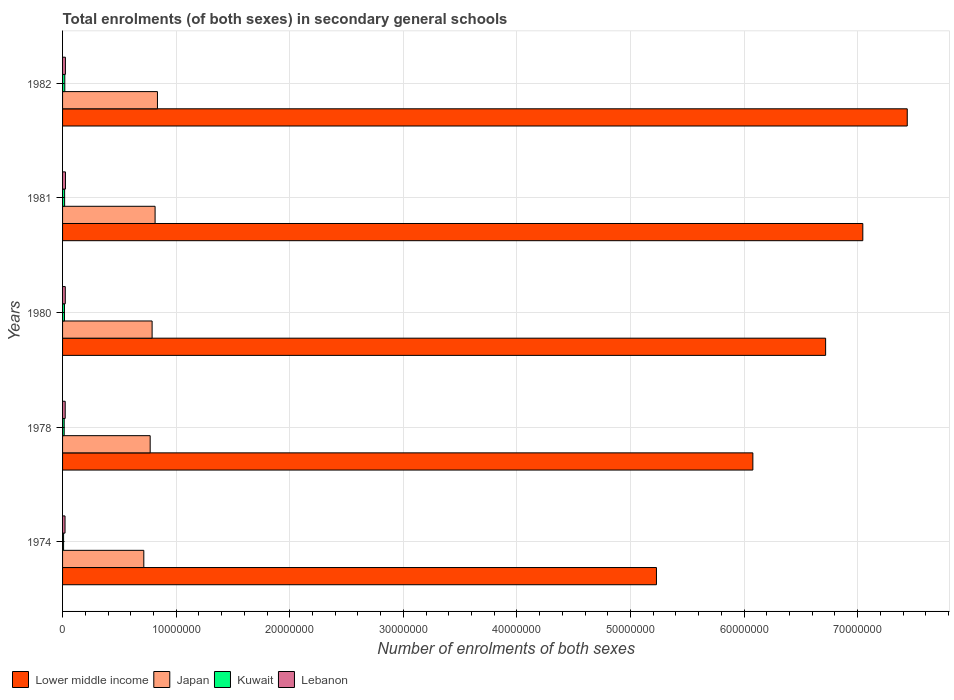Are the number of bars per tick equal to the number of legend labels?
Provide a short and direct response. Yes. How many bars are there on the 4th tick from the top?
Your response must be concise. 4. How many bars are there on the 1st tick from the bottom?
Your answer should be compact. 4. What is the label of the 1st group of bars from the top?
Your response must be concise. 1982. In how many cases, is the number of bars for a given year not equal to the number of legend labels?
Your answer should be compact. 0. What is the number of enrolments in secondary schools in Japan in 1980?
Make the answer very short. 7.88e+06. Across all years, what is the maximum number of enrolments in secondary schools in Japan?
Offer a terse response. 8.35e+06. Across all years, what is the minimum number of enrolments in secondary schools in Lower middle income?
Your answer should be compact. 5.23e+07. In which year was the number of enrolments in secondary schools in Kuwait maximum?
Offer a very short reply. 1982. In which year was the number of enrolments in secondary schools in Japan minimum?
Your answer should be very brief. 1974. What is the total number of enrolments in secondary schools in Lower middle income in the graph?
Provide a short and direct response. 3.25e+08. What is the difference between the number of enrolments in secondary schools in Lebanon in 1974 and that in 1982?
Keep it short and to the point. -3.33e+04. What is the difference between the number of enrolments in secondary schools in Japan in 1980 and the number of enrolments in secondary schools in Lebanon in 1974?
Provide a succinct answer. 7.67e+06. What is the average number of enrolments in secondary schools in Japan per year?
Offer a very short reply. 7.85e+06. In the year 1974, what is the difference between the number of enrolments in secondary schools in Lebanon and number of enrolments in secondary schools in Lower middle income?
Provide a succinct answer. -5.21e+07. In how many years, is the number of enrolments in secondary schools in Japan greater than 14000000 ?
Offer a terse response. 0. What is the ratio of the number of enrolments in secondary schools in Lebanon in 1981 to that in 1982?
Your answer should be compact. 1.02. Is the number of enrolments in secondary schools in Kuwait in 1974 less than that in 1982?
Make the answer very short. Yes. Is the difference between the number of enrolments in secondary schools in Lebanon in 1974 and 1982 greater than the difference between the number of enrolments in secondary schools in Lower middle income in 1974 and 1982?
Provide a succinct answer. Yes. What is the difference between the highest and the second highest number of enrolments in secondary schools in Lebanon?
Offer a very short reply. 4416. What is the difference between the highest and the lowest number of enrolments in secondary schools in Lebanon?
Ensure brevity in your answer.  3.77e+04. Is the sum of the number of enrolments in secondary schools in Lower middle income in 1978 and 1980 greater than the maximum number of enrolments in secondary schools in Lebanon across all years?
Make the answer very short. Yes. What does the 2nd bar from the top in 1982 represents?
Keep it short and to the point. Kuwait. What does the 3rd bar from the bottom in 1974 represents?
Give a very brief answer. Kuwait. Is it the case that in every year, the sum of the number of enrolments in secondary schools in Japan and number of enrolments in secondary schools in Lower middle income is greater than the number of enrolments in secondary schools in Kuwait?
Make the answer very short. Yes. How many bars are there?
Give a very brief answer. 20. Are all the bars in the graph horizontal?
Ensure brevity in your answer.  Yes. How many years are there in the graph?
Your response must be concise. 5. Are the values on the major ticks of X-axis written in scientific E-notation?
Offer a terse response. No. Does the graph contain any zero values?
Your answer should be compact. No. Does the graph contain grids?
Ensure brevity in your answer.  Yes. Where does the legend appear in the graph?
Ensure brevity in your answer.  Bottom left. What is the title of the graph?
Your answer should be very brief. Total enrolments (of both sexes) in secondary general schools. What is the label or title of the X-axis?
Keep it short and to the point. Number of enrolments of both sexes. What is the label or title of the Y-axis?
Keep it short and to the point. Years. What is the Number of enrolments of both sexes in Lower middle income in 1974?
Ensure brevity in your answer.  5.23e+07. What is the Number of enrolments of both sexes of Japan in 1974?
Ensure brevity in your answer.  7.15e+06. What is the Number of enrolments of both sexes of Kuwait in 1974?
Keep it short and to the point. 8.87e+04. What is the Number of enrolments of both sexes in Lebanon in 1974?
Offer a very short reply. 2.17e+05. What is the Number of enrolments of both sexes in Lower middle income in 1978?
Your answer should be very brief. 6.08e+07. What is the Number of enrolments of both sexes of Japan in 1978?
Your answer should be very brief. 7.71e+06. What is the Number of enrolments of both sexes of Kuwait in 1978?
Your answer should be compact. 1.43e+05. What is the Number of enrolments of both sexes of Lebanon in 1978?
Your answer should be very brief. 2.32e+05. What is the Number of enrolments of both sexes of Lower middle income in 1980?
Provide a succinct answer. 6.72e+07. What is the Number of enrolments of both sexes of Japan in 1980?
Keep it short and to the point. 7.88e+06. What is the Number of enrolments of both sexes of Kuwait in 1980?
Offer a very short reply. 1.67e+05. What is the Number of enrolments of both sexes in Lebanon in 1980?
Provide a short and direct response. 2.39e+05. What is the Number of enrolments of both sexes in Lower middle income in 1981?
Provide a succinct answer. 7.05e+07. What is the Number of enrolments of both sexes in Japan in 1981?
Offer a terse response. 8.15e+06. What is the Number of enrolments of both sexes in Kuwait in 1981?
Give a very brief answer. 1.81e+05. What is the Number of enrolments of both sexes in Lebanon in 1981?
Your answer should be very brief. 2.54e+05. What is the Number of enrolments of both sexes in Lower middle income in 1982?
Make the answer very short. 7.44e+07. What is the Number of enrolments of both sexes of Japan in 1982?
Your response must be concise. 8.35e+06. What is the Number of enrolments of both sexes of Kuwait in 1982?
Keep it short and to the point. 1.96e+05. What is the Number of enrolments of both sexes in Lebanon in 1982?
Offer a terse response. 2.50e+05. Across all years, what is the maximum Number of enrolments of both sexes of Lower middle income?
Provide a short and direct response. 7.44e+07. Across all years, what is the maximum Number of enrolments of both sexes of Japan?
Offer a very short reply. 8.35e+06. Across all years, what is the maximum Number of enrolments of both sexes in Kuwait?
Ensure brevity in your answer.  1.96e+05. Across all years, what is the maximum Number of enrolments of both sexes of Lebanon?
Make the answer very short. 2.54e+05. Across all years, what is the minimum Number of enrolments of both sexes in Lower middle income?
Your answer should be compact. 5.23e+07. Across all years, what is the minimum Number of enrolments of both sexes of Japan?
Your response must be concise. 7.15e+06. Across all years, what is the minimum Number of enrolments of both sexes of Kuwait?
Provide a short and direct response. 8.87e+04. Across all years, what is the minimum Number of enrolments of both sexes of Lebanon?
Keep it short and to the point. 2.17e+05. What is the total Number of enrolments of both sexes in Lower middle income in the graph?
Provide a short and direct response. 3.25e+08. What is the total Number of enrolments of both sexes in Japan in the graph?
Ensure brevity in your answer.  3.93e+07. What is the total Number of enrolments of both sexes in Kuwait in the graph?
Provide a short and direct response. 7.76e+05. What is the total Number of enrolments of both sexes in Lebanon in the graph?
Provide a succinct answer. 1.19e+06. What is the difference between the Number of enrolments of both sexes of Lower middle income in 1974 and that in 1978?
Provide a short and direct response. -8.49e+06. What is the difference between the Number of enrolments of both sexes in Japan in 1974 and that in 1978?
Provide a short and direct response. -5.60e+05. What is the difference between the Number of enrolments of both sexes of Kuwait in 1974 and that in 1978?
Your answer should be very brief. -5.38e+04. What is the difference between the Number of enrolments of both sexes in Lebanon in 1974 and that in 1978?
Your answer should be compact. -1.55e+04. What is the difference between the Number of enrolments of both sexes of Lower middle income in 1974 and that in 1980?
Keep it short and to the point. -1.49e+07. What is the difference between the Number of enrolments of both sexes in Japan in 1974 and that in 1980?
Your answer should be compact. -7.30e+05. What is the difference between the Number of enrolments of both sexes of Kuwait in 1974 and that in 1980?
Provide a succinct answer. -7.85e+04. What is the difference between the Number of enrolments of both sexes in Lebanon in 1974 and that in 1980?
Your answer should be very brief. -2.20e+04. What is the difference between the Number of enrolments of both sexes of Lower middle income in 1974 and that in 1981?
Provide a succinct answer. -1.82e+07. What is the difference between the Number of enrolments of both sexes of Japan in 1974 and that in 1981?
Ensure brevity in your answer.  -9.94e+05. What is the difference between the Number of enrolments of both sexes in Kuwait in 1974 and that in 1981?
Offer a very short reply. -9.27e+04. What is the difference between the Number of enrolments of both sexes in Lebanon in 1974 and that in 1981?
Your answer should be very brief. -3.77e+04. What is the difference between the Number of enrolments of both sexes in Lower middle income in 1974 and that in 1982?
Keep it short and to the point. -2.21e+07. What is the difference between the Number of enrolments of both sexes in Japan in 1974 and that in 1982?
Make the answer very short. -1.20e+06. What is the difference between the Number of enrolments of both sexes of Kuwait in 1974 and that in 1982?
Provide a succinct answer. -1.07e+05. What is the difference between the Number of enrolments of both sexes of Lebanon in 1974 and that in 1982?
Offer a terse response. -3.33e+04. What is the difference between the Number of enrolments of both sexes in Lower middle income in 1978 and that in 1980?
Offer a very short reply. -6.41e+06. What is the difference between the Number of enrolments of both sexes of Japan in 1978 and that in 1980?
Your response must be concise. -1.70e+05. What is the difference between the Number of enrolments of both sexes of Kuwait in 1978 and that in 1980?
Your answer should be compact. -2.47e+04. What is the difference between the Number of enrolments of both sexes of Lebanon in 1978 and that in 1980?
Ensure brevity in your answer.  -6518. What is the difference between the Number of enrolments of both sexes of Lower middle income in 1978 and that in 1981?
Offer a terse response. -9.68e+06. What is the difference between the Number of enrolments of both sexes in Japan in 1978 and that in 1981?
Your answer should be very brief. -4.34e+05. What is the difference between the Number of enrolments of both sexes in Kuwait in 1978 and that in 1981?
Your answer should be compact. -3.89e+04. What is the difference between the Number of enrolments of both sexes of Lebanon in 1978 and that in 1981?
Your response must be concise. -2.22e+04. What is the difference between the Number of enrolments of both sexes in Lower middle income in 1978 and that in 1982?
Keep it short and to the point. -1.36e+07. What is the difference between the Number of enrolments of both sexes in Japan in 1978 and that in 1982?
Your answer should be compact. -6.41e+05. What is the difference between the Number of enrolments of both sexes in Kuwait in 1978 and that in 1982?
Provide a succinct answer. -5.32e+04. What is the difference between the Number of enrolments of both sexes in Lebanon in 1978 and that in 1982?
Offer a terse response. -1.78e+04. What is the difference between the Number of enrolments of both sexes of Lower middle income in 1980 and that in 1981?
Give a very brief answer. -3.27e+06. What is the difference between the Number of enrolments of both sexes in Japan in 1980 and that in 1981?
Provide a short and direct response. -2.63e+05. What is the difference between the Number of enrolments of both sexes in Kuwait in 1980 and that in 1981?
Offer a very short reply. -1.42e+04. What is the difference between the Number of enrolments of both sexes in Lebanon in 1980 and that in 1981?
Keep it short and to the point. -1.57e+04. What is the difference between the Number of enrolments of both sexes of Lower middle income in 1980 and that in 1982?
Offer a terse response. -7.19e+06. What is the difference between the Number of enrolments of both sexes of Japan in 1980 and that in 1982?
Your response must be concise. -4.71e+05. What is the difference between the Number of enrolments of both sexes in Kuwait in 1980 and that in 1982?
Your answer should be very brief. -2.85e+04. What is the difference between the Number of enrolments of both sexes in Lebanon in 1980 and that in 1982?
Keep it short and to the point. -1.13e+04. What is the difference between the Number of enrolments of both sexes of Lower middle income in 1981 and that in 1982?
Ensure brevity in your answer.  -3.91e+06. What is the difference between the Number of enrolments of both sexes in Japan in 1981 and that in 1982?
Your response must be concise. -2.07e+05. What is the difference between the Number of enrolments of both sexes in Kuwait in 1981 and that in 1982?
Offer a terse response. -1.43e+04. What is the difference between the Number of enrolments of both sexes in Lebanon in 1981 and that in 1982?
Provide a short and direct response. 4416. What is the difference between the Number of enrolments of both sexes in Lower middle income in 1974 and the Number of enrolments of both sexes in Japan in 1978?
Ensure brevity in your answer.  4.46e+07. What is the difference between the Number of enrolments of both sexes in Lower middle income in 1974 and the Number of enrolments of both sexes in Kuwait in 1978?
Your response must be concise. 5.21e+07. What is the difference between the Number of enrolments of both sexes in Lower middle income in 1974 and the Number of enrolments of both sexes in Lebanon in 1978?
Offer a very short reply. 5.21e+07. What is the difference between the Number of enrolments of both sexes of Japan in 1974 and the Number of enrolments of both sexes of Kuwait in 1978?
Provide a short and direct response. 7.01e+06. What is the difference between the Number of enrolments of both sexes in Japan in 1974 and the Number of enrolments of both sexes in Lebanon in 1978?
Keep it short and to the point. 6.92e+06. What is the difference between the Number of enrolments of both sexes in Kuwait in 1974 and the Number of enrolments of both sexes in Lebanon in 1978?
Offer a very short reply. -1.44e+05. What is the difference between the Number of enrolments of both sexes of Lower middle income in 1974 and the Number of enrolments of both sexes of Japan in 1980?
Give a very brief answer. 4.44e+07. What is the difference between the Number of enrolments of both sexes in Lower middle income in 1974 and the Number of enrolments of both sexes in Kuwait in 1980?
Your answer should be very brief. 5.21e+07. What is the difference between the Number of enrolments of both sexes in Lower middle income in 1974 and the Number of enrolments of both sexes in Lebanon in 1980?
Offer a terse response. 5.20e+07. What is the difference between the Number of enrolments of both sexes of Japan in 1974 and the Number of enrolments of both sexes of Kuwait in 1980?
Provide a short and direct response. 6.99e+06. What is the difference between the Number of enrolments of both sexes of Japan in 1974 and the Number of enrolments of both sexes of Lebanon in 1980?
Make the answer very short. 6.91e+06. What is the difference between the Number of enrolments of both sexes of Kuwait in 1974 and the Number of enrolments of both sexes of Lebanon in 1980?
Your response must be concise. -1.50e+05. What is the difference between the Number of enrolments of both sexes in Lower middle income in 1974 and the Number of enrolments of both sexes in Japan in 1981?
Your answer should be compact. 4.41e+07. What is the difference between the Number of enrolments of both sexes in Lower middle income in 1974 and the Number of enrolments of both sexes in Kuwait in 1981?
Give a very brief answer. 5.21e+07. What is the difference between the Number of enrolments of both sexes in Lower middle income in 1974 and the Number of enrolments of both sexes in Lebanon in 1981?
Offer a very short reply. 5.20e+07. What is the difference between the Number of enrolments of both sexes in Japan in 1974 and the Number of enrolments of both sexes in Kuwait in 1981?
Ensure brevity in your answer.  6.97e+06. What is the difference between the Number of enrolments of both sexes in Japan in 1974 and the Number of enrolments of both sexes in Lebanon in 1981?
Make the answer very short. 6.90e+06. What is the difference between the Number of enrolments of both sexes in Kuwait in 1974 and the Number of enrolments of both sexes in Lebanon in 1981?
Make the answer very short. -1.66e+05. What is the difference between the Number of enrolments of both sexes of Lower middle income in 1974 and the Number of enrolments of both sexes of Japan in 1982?
Make the answer very short. 4.39e+07. What is the difference between the Number of enrolments of both sexes of Lower middle income in 1974 and the Number of enrolments of both sexes of Kuwait in 1982?
Your answer should be very brief. 5.21e+07. What is the difference between the Number of enrolments of both sexes of Lower middle income in 1974 and the Number of enrolments of both sexes of Lebanon in 1982?
Offer a very short reply. 5.20e+07. What is the difference between the Number of enrolments of both sexes of Japan in 1974 and the Number of enrolments of both sexes of Kuwait in 1982?
Keep it short and to the point. 6.96e+06. What is the difference between the Number of enrolments of both sexes of Japan in 1974 and the Number of enrolments of both sexes of Lebanon in 1982?
Your answer should be very brief. 6.90e+06. What is the difference between the Number of enrolments of both sexes in Kuwait in 1974 and the Number of enrolments of both sexes in Lebanon in 1982?
Ensure brevity in your answer.  -1.61e+05. What is the difference between the Number of enrolments of both sexes in Lower middle income in 1978 and the Number of enrolments of both sexes in Japan in 1980?
Provide a short and direct response. 5.29e+07. What is the difference between the Number of enrolments of both sexes in Lower middle income in 1978 and the Number of enrolments of both sexes in Kuwait in 1980?
Provide a short and direct response. 6.06e+07. What is the difference between the Number of enrolments of both sexes of Lower middle income in 1978 and the Number of enrolments of both sexes of Lebanon in 1980?
Your answer should be compact. 6.05e+07. What is the difference between the Number of enrolments of both sexes of Japan in 1978 and the Number of enrolments of both sexes of Kuwait in 1980?
Provide a short and direct response. 7.55e+06. What is the difference between the Number of enrolments of both sexes of Japan in 1978 and the Number of enrolments of both sexes of Lebanon in 1980?
Your answer should be compact. 7.47e+06. What is the difference between the Number of enrolments of both sexes in Kuwait in 1978 and the Number of enrolments of both sexes in Lebanon in 1980?
Make the answer very short. -9.63e+04. What is the difference between the Number of enrolments of both sexes in Lower middle income in 1978 and the Number of enrolments of both sexes in Japan in 1981?
Provide a short and direct response. 5.26e+07. What is the difference between the Number of enrolments of both sexes in Lower middle income in 1978 and the Number of enrolments of both sexes in Kuwait in 1981?
Offer a terse response. 6.06e+07. What is the difference between the Number of enrolments of both sexes in Lower middle income in 1978 and the Number of enrolments of both sexes in Lebanon in 1981?
Give a very brief answer. 6.05e+07. What is the difference between the Number of enrolments of both sexes in Japan in 1978 and the Number of enrolments of both sexes in Kuwait in 1981?
Provide a short and direct response. 7.53e+06. What is the difference between the Number of enrolments of both sexes in Japan in 1978 and the Number of enrolments of both sexes in Lebanon in 1981?
Offer a very short reply. 7.46e+06. What is the difference between the Number of enrolments of both sexes of Kuwait in 1978 and the Number of enrolments of both sexes of Lebanon in 1981?
Your answer should be very brief. -1.12e+05. What is the difference between the Number of enrolments of both sexes of Lower middle income in 1978 and the Number of enrolments of both sexes of Japan in 1982?
Your answer should be compact. 5.24e+07. What is the difference between the Number of enrolments of both sexes of Lower middle income in 1978 and the Number of enrolments of both sexes of Kuwait in 1982?
Offer a very short reply. 6.06e+07. What is the difference between the Number of enrolments of both sexes in Lower middle income in 1978 and the Number of enrolments of both sexes in Lebanon in 1982?
Provide a short and direct response. 6.05e+07. What is the difference between the Number of enrolments of both sexes of Japan in 1978 and the Number of enrolments of both sexes of Kuwait in 1982?
Offer a very short reply. 7.52e+06. What is the difference between the Number of enrolments of both sexes of Japan in 1978 and the Number of enrolments of both sexes of Lebanon in 1982?
Your answer should be compact. 7.46e+06. What is the difference between the Number of enrolments of both sexes in Kuwait in 1978 and the Number of enrolments of both sexes in Lebanon in 1982?
Provide a succinct answer. -1.08e+05. What is the difference between the Number of enrolments of both sexes of Lower middle income in 1980 and the Number of enrolments of both sexes of Japan in 1981?
Give a very brief answer. 5.90e+07. What is the difference between the Number of enrolments of both sexes in Lower middle income in 1980 and the Number of enrolments of both sexes in Kuwait in 1981?
Your answer should be compact. 6.70e+07. What is the difference between the Number of enrolments of both sexes of Lower middle income in 1980 and the Number of enrolments of both sexes of Lebanon in 1981?
Keep it short and to the point. 6.69e+07. What is the difference between the Number of enrolments of both sexes of Japan in 1980 and the Number of enrolments of both sexes of Kuwait in 1981?
Offer a very short reply. 7.70e+06. What is the difference between the Number of enrolments of both sexes of Japan in 1980 and the Number of enrolments of both sexes of Lebanon in 1981?
Ensure brevity in your answer.  7.63e+06. What is the difference between the Number of enrolments of both sexes in Kuwait in 1980 and the Number of enrolments of both sexes in Lebanon in 1981?
Give a very brief answer. -8.72e+04. What is the difference between the Number of enrolments of both sexes in Lower middle income in 1980 and the Number of enrolments of both sexes in Japan in 1982?
Ensure brevity in your answer.  5.88e+07. What is the difference between the Number of enrolments of both sexes in Lower middle income in 1980 and the Number of enrolments of both sexes in Kuwait in 1982?
Keep it short and to the point. 6.70e+07. What is the difference between the Number of enrolments of both sexes of Lower middle income in 1980 and the Number of enrolments of both sexes of Lebanon in 1982?
Your answer should be very brief. 6.69e+07. What is the difference between the Number of enrolments of both sexes of Japan in 1980 and the Number of enrolments of both sexes of Kuwait in 1982?
Offer a terse response. 7.69e+06. What is the difference between the Number of enrolments of both sexes of Japan in 1980 and the Number of enrolments of both sexes of Lebanon in 1982?
Your answer should be very brief. 7.63e+06. What is the difference between the Number of enrolments of both sexes in Kuwait in 1980 and the Number of enrolments of both sexes in Lebanon in 1982?
Your response must be concise. -8.28e+04. What is the difference between the Number of enrolments of both sexes in Lower middle income in 1981 and the Number of enrolments of both sexes in Japan in 1982?
Provide a short and direct response. 6.21e+07. What is the difference between the Number of enrolments of both sexes of Lower middle income in 1981 and the Number of enrolments of both sexes of Kuwait in 1982?
Provide a succinct answer. 7.03e+07. What is the difference between the Number of enrolments of both sexes in Lower middle income in 1981 and the Number of enrolments of both sexes in Lebanon in 1982?
Give a very brief answer. 7.02e+07. What is the difference between the Number of enrolments of both sexes of Japan in 1981 and the Number of enrolments of both sexes of Kuwait in 1982?
Your answer should be compact. 7.95e+06. What is the difference between the Number of enrolments of both sexes in Japan in 1981 and the Number of enrolments of both sexes in Lebanon in 1982?
Provide a short and direct response. 7.90e+06. What is the difference between the Number of enrolments of both sexes of Kuwait in 1981 and the Number of enrolments of both sexes of Lebanon in 1982?
Your response must be concise. -6.86e+04. What is the average Number of enrolments of both sexes of Lower middle income per year?
Keep it short and to the point. 6.50e+07. What is the average Number of enrolments of both sexes of Japan per year?
Your response must be concise. 7.85e+06. What is the average Number of enrolments of both sexes in Kuwait per year?
Your answer should be very brief. 1.55e+05. What is the average Number of enrolments of both sexes in Lebanon per year?
Make the answer very short. 2.38e+05. In the year 1974, what is the difference between the Number of enrolments of both sexes in Lower middle income and Number of enrolments of both sexes in Japan?
Ensure brevity in your answer.  4.51e+07. In the year 1974, what is the difference between the Number of enrolments of both sexes in Lower middle income and Number of enrolments of both sexes in Kuwait?
Your answer should be very brief. 5.22e+07. In the year 1974, what is the difference between the Number of enrolments of both sexes in Lower middle income and Number of enrolments of both sexes in Lebanon?
Your response must be concise. 5.21e+07. In the year 1974, what is the difference between the Number of enrolments of both sexes of Japan and Number of enrolments of both sexes of Kuwait?
Ensure brevity in your answer.  7.06e+06. In the year 1974, what is the difference between the Number of enrolments of both sexes in Japan and Number of enrolments of both sexes in Lebanon?
Give a very brief answer. 6.94e+06. In the year 1974, what is the difference between the Number of enrolments of both sexes in Kuwait and Number of enrolments of both sexes in Lebanon?
Give a very brief answer. -1.28e+05. In the year 1978, what is the difference between the Number of enrolments of both sexes of Lower middle income and Number of enrolments of both sexes of Japan?
Provide a short and direct response. 5.31e+07. In the year 1978, what is the difference between the Number of enrolments of both sexes of Lower middle income and Number of enrolments of both sexes of Kuwait?
Offer a terse response. 6.06e+07. In the year 1978, what is the difference between the Number of enrolments of both sexes in Lower middle income and Number of enrolments of both sexes in Lebanon?
Provide a succinct answer. 6.05e+07. In the year 1978, what is the difference between the Number of enrolments of both sexes of Japan and Number of enrolments of both sexes of Kuwait?
Your answer should be compact. 7.57e+06. In the year 1978, what is the difference between the Number of enrolments of both sexes of Japan and Number of enrolments of both sexes of Lebanon?
Offer a very short reply. 7.48e+06. In the year 1978, what is the difference between the Number of enrolments of both sexes in Kuwait and Number of enrolments of both sexes in Lebanon?
Provide a succinct answer. -8.97e+04. In the year 1980, what is the difference between the Number of enrolments of both sexes of Lower middle income and Number of enrolments of both sexes of Japan?
Make the answer very short. 5.93e+07. In the year 1980, what is the difference between the Number of enrolments of both sexes in Lower middle income and Number of enrolments of both sexes in Kuwait?
Offer a terse response. 6.70e+07. In the year 1980, what is the difference between the Number of enrolments of both sexes of Lower middle income and Number of enrolments of both sexes of Lebanon?
Give a very brief answer. 6.69e+07. In the year 1980, what is the difference between the Number of enrolments of both sexes in Japan and Number of enrolments of both sexes in Kuwait?
Your answer should be compact. 7.72e+06. In the year 1980, what is the difference between the Number of enrolments of both sexes of Japan and Number of enrolments of both sexes of Lebanon?
Your response must be concise. 7.64e+06. In the year 1980, what is the difference between the Number of enrolments of both sexes in Kuwait and Number of enrolments of both sexes in Lebanon?
Provide a succinct answer. -7.15e+04. In the year 1981, what is the difference between the Number of enrolments of both sexes in Lower middle income and Number of enrolments of both sexes in Japan?
Provide a succinct answer. 6.23e+07. In the year 1981, what is the difference between the Number of enrolments of both sexes of Lower middle income and Number of enrolments of both sexes of Kuwait?
Your answer should be compact. 7.03e+07. In the year 1981, what is the difference between the Number of enrolments of both sexes in Lower middle income and Number of enrolments of both sexes in Lebanon?
Keep it short and to the point. 7.02e+07. In the year 1981, what is the difference between the Number of enrolments of both sexes of Japan and Number of enrolments of both sexes of Kuwait?
Your answer should be compact. 7.97e+06. In the year 1981, what is the difference between the Number of enrolments of both sexes of Japan and Number of enrolments of both sexes of Lebanon?
Provide a short and direct response. 7.89e+06. In the year 1981, what is the difference between the Number of enrolments of both sexes in Kuwait and Number of enrolments of both sexes in Lebanon?
Provide a short and direct response. -7.30e+04. In the year 1982, what is the difference between the Number of enrolments of both sexes of Lower middle income and Number of enrolments of both sexes of Japan?
Give a very brief answer. 6.60e+07. In the year 1982, what is the difference between the Number of enrolments of both sexes in Lower middle income and Number of enrolments of both sexes in Kuwait?
Your answer should be very brief. 7.42e+07. In the year 1982, what is the difference between the Number of enrolments of both sexes of Lower middle income and Number of enrolments of both sexes of Lebanon?
Provide a succinct answer. 7.41e+07. In the year 1982, what is the difference between the Number of enrolments of both sexes of Japan and Number of enrolments of both sexes of Kuwait?
Provide a succinct answer. 8.16e+06. In the year 1982, what is the difference between the Number of enrolments of both sexes of Japan and Number of enrolments of both sexes of Lebanon?
Provide a short and direct response. 8.10e+06. In the year 1982, what is the difference between the Number of enrolments of both sexes in Kuwait and Number of enrolments of both sexes in Lebanon?
Your answer should be very brief. -5.43e+04. What is the ratio of the Number of enrolments of both sexes of Lower middle income in 1974 to that in 1978?
Your answer should be very brief. 0.86. What is the ratio of the Number of enrolments of both sexes in Japan in 1974 to that in 1978?
Give a very brief answer. 0.93. What is the ratio of the Number of enrolments of both sexes in Kuwait in 1974 to that in 1978?
Make the answer very short. 0.62. What is the ratio of the Number of enrolments of both sexes in Lebanon in 1974 to that in 1978?
Give a very brief answer. 0.93. What is the ratio of the Number of enrolments of both sexes of Lower middle income in 1974 to that in 1980?
Provide a short and direct response. 0.78. What is the ratio of the Number of enrolments of both sexes in Japan in 1974 to that in 1980?
Provide a short and direct response. 0.91. What is the ratio of the Number of enrolments of both sexes of Kuwait in 1974 to that in 1980?
Give a very brief answer. 0.53. What is the ratio of the Number of enrolments of both sexes of Lebanon in 1974 to that in 1980?
Keep it short and to the point. 0.91. What is the ratio of the Number of enrolments of both sexes in Lower middle income in 1974 to that in 1981?
Provide a succinct answer. 0.74. What is the ratio of the Number of enrolments of both sexes of Japan in 1974 to that in 1981?
Provide a short and direct response. 0.88. What is the ratio of the Number of enrolments of both sexes of Kuwait in 1974 to that in 1981?
Provide a succinct answer. 0.49. What is the ratio of the Number of enrolments of both sexes of Lebanon in 1974 to that in 1981?
Keep it short and to the point. 0.85. What is the ratio of the Number of enrolments of both sexes in Lower middle income in 1974 to that in 1982?
Keep it short and to the point. 0.7. What is the ratio of the Number of enrolments of both sexes of Japan in 1974 to that in 1982?
Provide a succinct answer. 0.86. What is the ratio of the Number of enrolments of both sexes in Kuwait in 1974 to that in 1982?
Provide a succinct answer. 0.45. What is the ratio of the Number of enrolments of both sexes of Lebanon in 1974 to that in 1982?
Your answer should be compact. 0.87. What is the ratio of the Number of enrolments of both sexes of Lower middle income in 1978 to that in 1980?
Keep it short and to the point. 0.9. What is the ratio of the Number of enrolments of both sexes in Japan in 1978 to that in 1980?
Your answer should be very brief. 0.98. What is the ratio of the Number of enrolments of both sexes of Kuwait in 1978 to that in 1980?
Your response must be concise. 0.85. What is the ratio of the Number of enrolments of both sexes of Lebanon in 1978 to that in 1980?
Offer a very short reply. 0.97. What is the ratio of the Number of enrolments of both sexes in Lower middle income in 1978 to that in 1981?
Provide a succinct answer. 0.86. What is the ratio of the Number of enrolments of both sexes of Japan in 1978 to that in 1981?
Your response must be concise. 0.95. What is the ratio of the Number of enrolments of both sexes in Kuwait in 1978 to that in 1981?
Provide a short and direct response. 0.79. What is the ratio of the Number of enrolments of both sexes in Lebanon in 1978 to that in 1981?
Give a very brief answer. 0.91. What is the ratio of the Number of enrolments of both sexes of Lower middle income in 1978 to that in 1982?
Ensure brevity in your answer.  0.82. What is the ratio of the Number of enrolments of both sexes in Japan in 1978 to that in 1982?
Your response must be concise. 0.92. What is the ratio of the Number of enrolments of both sexes in Kuwait in 1978 to that in 1982?
Your response must be concise. 0.73. What is the ratio of the Number of enrolments of both sexes of Lebanon in 1978 to that in 1982?
Ensure brevity in your answer.  0.93. What is the ratio of the Number of enrolments of both sexes of Lower middle income in 1980 to that in 1981?
Offer a terse response. 0.95. What is the ratio of the Number of enrolments of both sexes of Japan in 1980 to that in 1981?
Give a very brief answer. 0.97. What is the ratio of the Number of enrolments of both sexes of Kuwait in 1980 to that in 1981?
Your response must be concise. 0.92. What is the ratio of the Number of enrolments of both sexes in Lebanon in 1980 to that in 1981?
Your answer should be compact. 0.94. What is the ratio of the Number of enrolments of both sexes of Lower middle income in 1980 to that in 1982?
Keep it short and to the point. 0.9. What is the ratio of the Number of enrolments of both sexes in Japan in 1980 to that in 1982?
Keep it short and to the point. 0.94. What is the ratio of the Number of enrolments of both sexes in Kuwait in 1980 to that in 1982?
Keep it short and to the point. 0.85. What is the ratio of the Number of enrolments of both sexes of Lebanon in 1980 to that in 1982?
Your answer should be very brief. 0.95. What is the ratio of the Number of enrolments of both sexes of Lower middle income in 1981 to that in 1982?
Offer a very short reply. 0.95. What is the ratio of the Number of enrolments of both sexes in Japan in 1981 to that in 1982?
Your response must be concise. 0.98. What is the ratio of the Number of enrolments of both sexes of Kuwait in 1981 to that in 1982?
Offer a terse response. 0.93. What is the ratio of the Number of enrolments of both sexes in Lebanon in 1981 to that in 1982?
Make the answer very short. 1.02. What is the difference between the highest and the second highest Number of enrolments of both sexes in Lower middle income?
Provide a succinct answer. 3.91e+06. What is the difference between the highest and the second highest Number of enrolments of both sexes of Japan?
Give a very brief answer. 2.07e+05. What is the difference between the highest and the second highest Number of enrolments of both sexes of Kuwait?
Your answer should be very brief. 1.43e+04. What is the difference between the highest and the second highest Number of enrolments of both sexes in Lebanon?
Offer a terse response. 4416. What is the difference between the highest and the lowest Number of enrolments of both sexes in Lower middle income?
Your response must be concise. 2.21e+07. What is the difference between the highest and the lowest Number of enrolments of both sexes in Japan?
Provide a short and direct response. 1.20e+06. What is the difference between the highest and the lowest Number of enrolments of both sexes in Kuwait?
Keep it short and to the point. 1.07e+05. What is the difference between the highest and the lowest Number of enrolments of both sexes in Lebanon?
Offer a very short reply. 3.77e+04. 